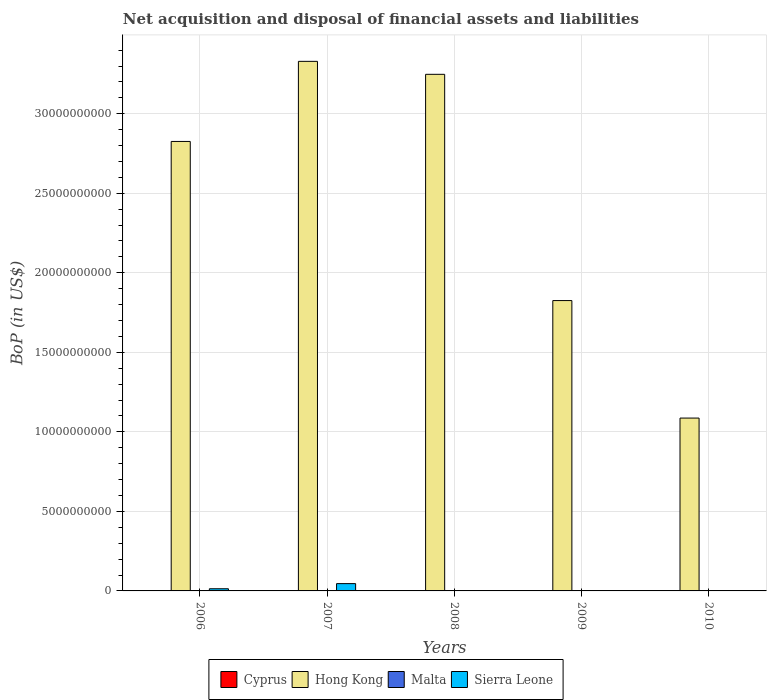Are the number of bars per tick equal to the number of legend labels?
Offer a terse response. No. Are the number of bars on each tick of the X-axis equal?
Ensure brevity in your answer.  No. What is the label of the 2nd group of bars from the left?
Keep it short and to the point. 2007. In how many cases, is the number of bars for a given year not equal to the number of legend labels?
Ensure brevity in your answer.  5. Across all years, what is the maximum Balance of Payments in Sierra Leone?
Offer a very short reply. 4.59e+08. Across all years, what is the minimum Balance of Payments in Cyprus?
Offer a very short reply. 0. In which year was the Balance of Payments in Sierra Leone maximum?
Offer a terse response. 2007. What is the difference between the Balance of Payments in Hong Kong in 2007 and that in 2008?
Ensure brevity in your answer.  8.15e+08. What is the difference between the Balance of Payments in Sierra Leone in 2010 and the Balance of Payments in Malta in 2009?
Provide a succinct answer. 0. What is the average Balance of Payments in Sierra Leone per year?
Make the answer very short. 1.19e+08. In the year 2006, what is the difference between the Balance of Payments in Hong Kong and Balance of Payments in Sierra Leone?
Offer a very short reply. 2.81e+1. What is the ratio of the Balance of Payments in Hong Kong in 2007 to that in 2008?
Offer a very short reply. 1.03. Is the Balance of Payments in Hong Kong in 2006 less than that in 2008?
Provide a succinct answer. Yes. What is the difference between the highest and the second highest Balance of Payments in Hong Kong?
Give a very brief answer. 8.15e+08. What is the difference between the highest and the lowest Balance of Payments in Sierra Leone?
Provide a succinct answer. 4.59e+08. Is it the case that in every year, the sum of the Balance of Payments in Cyprus and Balance of Payments in Sierra Leone is greater than the Balance of Payments in Malta?
Your answer should be very brief. No. Are the values on the major ticks of Y-axis written in scientific E-notation?
Your response must be concise. No. Where does the legend appear in the graph?
Your answer should be compact. Bottom center. How many legend labels are there?
Keep it short and to the point. 4. What is the title of the graph?
Provide a succinct answer. Net acquisition and disposal of financial assets and liabilities. What is the label or title of the Y-axis?
Keep it short and to the point. BoP (in US$). What is the BoP (in US$) in Cyprus in 2006?
Offer a very short reply. 0. What is the BoP (in US$) in Hong Kong in 2006?
Your response must be concise. 2.83e+1. What is the BoP (in US$) of Sierra Leone in 2006?
Provide a short and direct response. 1.36e+08. What is the BoP (in US$) in Hong Kong in 2007?
Provide a short and direct response. 3.33e+1. What is the BoP (in US$) in Malta in 2007?
Ensure brevity in your answer.  0. What is the BoP (in US$) in Sierra Leone in 2007?
Your answer should be compact. 4.59e+08. What is the BoP (in US$) of Hong Kong in 2008?
Your answer should be compact. 3.25e+1. What is the BoP (in US$) of Malta in 2008?
Your response must be concise. 0. What is the BoP (in US$) in Cyprus in 2009?
Ensure brevity in your answer.  0. What is the BoP (in US$) of Hong Kong in 2009?
Provide a succinct answer. 1.83e+1. What is the BoP (in US$) of Malta in 2009?
Keep it short and to the point. 0. What is the BoP (in US$) in Cyprus in 2010?
Your answer should be compact. 0. What is the BoP (in US$) of Hong Kong in 2010?
Keep it short and to the point. 1.09e+1. What is the BoP (in US$) of Malta in 2010?
Your answer should be compact. 0. What is the BoP (in US$) in Sierra Leone in 2010?
Your response must be concise. 0. Across all years, what is the maximum BoP (in US$) in Hong Kong?
Give a very brief answer. 3.33e+1. Across all years, what is the maximum BoP (in US$) of Sierra Leone?
Your answer should be very brief. 4.59e+08. Across all years, what is the minimum BoP (in US$) of Hong Kong?
Keep it short and to the point. 1.09e+1. Across all years, what is the minimum BoP (in US$) of Sierra Leone?
Ensure brevity in your answer.  0. What is the total BoP (in US$) of Hong Kong in the graph?
Provide a short and direct response. 1.23e+11. What is the total BoP (in US$) of Sierra Leone in the graph?
Your answer should be very brief. 5.95e+08. What is the difference between the BoP (in US$) of Hong Kong in 2006 and that in 2007?
Your answer should be very brief. -5.04e+09. What is the difference between the BoP (in US$) of Sierra Leone in 2006 and that in 2007?
Provide a succinct answer. -3.23e+08. What is the difference between the BoP (in US$) in Hong Kong in 2006 and that in 2008?
Make the answer very short. -4.22e+09. What is the difference between the BoP (in US$) of Hong Kong in 2006 and that in 2009?
Your response must be concise. 1.00e+1. What is the difference between the BoP (in US$) of Hong Kong in 2006 and that in 2010?
Ensure brevity in your answer.  1.74e+1. What is the difference between the BoP (in US$) of Hong Kong in 2007 and that in 2008?
Your answer should be compact. 8.15e+08. What is the difference between the BoP (in US$) of Hong Kong in 2007 and that in 2009?
Keep it short and to the point. 1.50e+1. What is the difference between the BoP (in US$) of Hong Kong in 2007 and that in 2010?
Your answer should be compact. 2.24e+1. What is the difference between the BoP (in US$) in Hong Kong in 2008 and that in 2009?
Provide a short and direct response. 1.42e+1. What is the difference between the BoP (in US$) in Hong Kong in 2008 and that in 2010?
Offer a very short reply. 2.16e+1. What is the difference between the BoP (in US$) of Hong Kong in 2009 and that in 2010?
Your answer should be compact. 7.39e+09. What is the difference between the BoP (in US$) in Hong Kong in 2006 and the BoP (in US$) in Sierra Leone in 2007?
Ensure brevity in your answer.  2.78e+1. What is the average BoP (in US$) in Cyprus per year?
Make the answer very short. 0. What is the average BoP (in US$) of Hong Kong per year?
Your answer should be compact. 2.46e+1. What is the average BoP (in US$) in Malta per year?
Provide a succinct answer. 0. What is the average BoP (in US$) in Sierra Leone per year?
Offer a very short reply. 1.19e+08. In the year 2006, what is the difference between the BoP (in US$) in Hong Kong and BoP (in US$) in Sierra Leone?
Keep it short and to the point. 2.81e+1. In the year 2007, what is the difference between the BoP (in US$) in Hong Kong and BoP (in US$) in Sierra Leone?
Give a very brief answer. 3.28e+1. What is the ratio of the BoP (in US$) in Hong Kong in 2006 to that in 2007?
Make the answer very short. 0.85. What is the ratio of the BoP (in US$) of Sierra Leone in 2006 to that in 2007?
Offer a terse response. 0.3. What is the ratio of the BoP (in US$) in Hong Kong in 2006 to that in 2008?
Your answer should be very brief. 0.87. What is the ratio of the BoP (in US$) in Hong Kong in 2006 to that in 2009?
Provide a succinct answer. 1.55. What is the ratio of the BoP (in US$) in Hong Kong in 2006 to that in 2010?
Make the answer very short. 2.6. What is the ratio of the BoP (in US$) in Hong Kong in 2007 to that in 2008?
Your answer should be compact. 1.03. What is the ratio of the BoP (in US$) in Hong Kong in 2007 to that in 2009?
Your response must be concise. 1.82. What is the ratio of the BoP (in US$) of Hong Kong in 2007 to that in 2010?
Ensure brevity in your answer.  3.06. What is the ratio of the BoP (in US$) of Hong Kong in 2008 to that in 2009?
Keep it short and to the point. 1.78. What is the ratio of the BoP (in US$) in Hong Kong in 2008 to that in 2010?
Give a very brief answer. 2.99. What is the ratio of the BoP (in US$) in Hong Kong in 2009 to that in 2010?
Offer a terse response. 1.68. What is the difference between the highest and the second highest BoP (in US$) in Hong Kong?
Ensure brevity in your answer.  8.15e+08. What is the difference between the highest and the lowest BoP (in US$) in Hong Kong?
Your response must be concise. 2.24e+1. What is the difference between the highest and the lowest BoP (in US$) of Sierra Leone?
Your answer should be compact. 4.59e+08. 